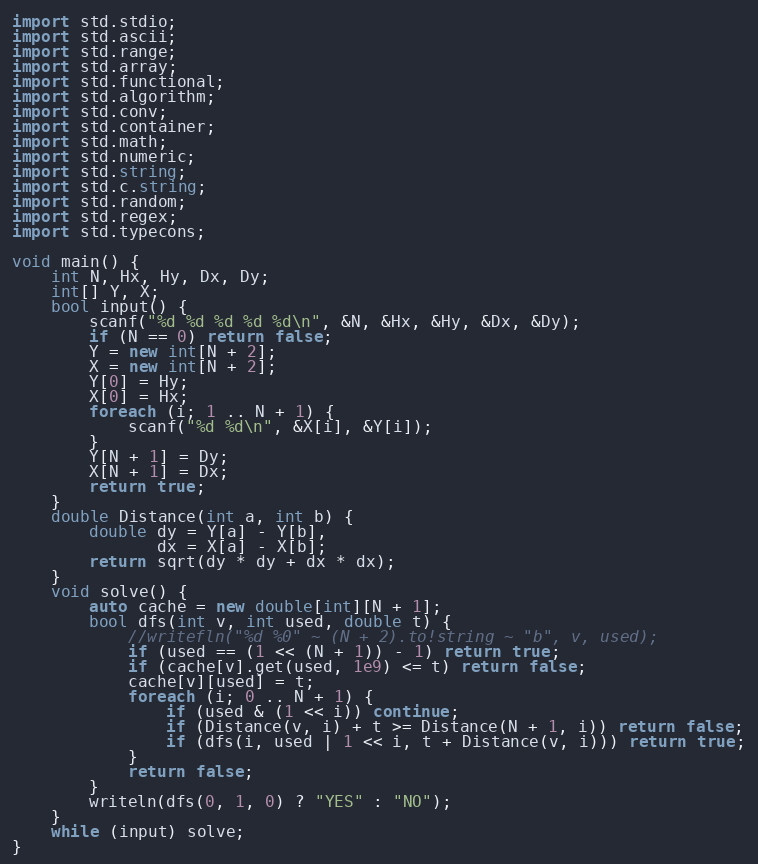<code> <loc_0><loc_0><loc_500><loc_500><_D_>import std.stdio;
import std.ascii;
import std.range;
import std.array;
import std.functional;
import std.algorithm;
import std.conv;
import std.container;
import std.math;
import std.numeric;
import std.string;
import std.c.string;
import std.random;
import std.regex;
import std.typecons;

void main() {
    int N, Hx, Hy, Dx, Dy;
    int[] Y, X;
    bool input() {
        scanf("%d %d %d %d %d\n", &N, &Hx, &Hy, &Dx, &Dy);
        if (N == 0) return false;
        Y = new int[N + 2];
        X = new int[N + 2];
        Y[0] = Hy;
        X[0] = Hx;
        foreach (i; 1 .. N + 1) {
            scanf("%d %d\n", &X[i], &Y[i]);
        }
        Y[N + 1] = Dy;
        X[N + 1] = Dx;
        return true;
    }
    double Distance(int a, int b) {
        double dy = Y[a] - Y[b],
               dx = X[a] - X[b];
        return sqrt(dy * dy + dx * dx);
    }
    void solve() {
        auto cache = new double[int][N + 1];
        bool dfs(int v, int used, double t) {
            //writefln("%d %0" ~ (N + 2).to!string ~ "b", v, used);
            if (used == (1 << (N + 1)) - 1) return true;
            if (cache[v].get(used, 1e9) <= t) return false;
            cache[v][used] = t;
            foreach (i; 0 .. N + 1) {
                if (used & (1 << i)) continue;
                if (Distance(v, i) + t >= Distance(N + 1, i)) return false;
                if (dfs(i, used | 1 << i, t + Distance(v, i))) return true;
            }
            return false;
        }
        writeln(dfs(0, 1, 0) ? "YES" : "NO");
    }
    while (input) solve;
}</code> 